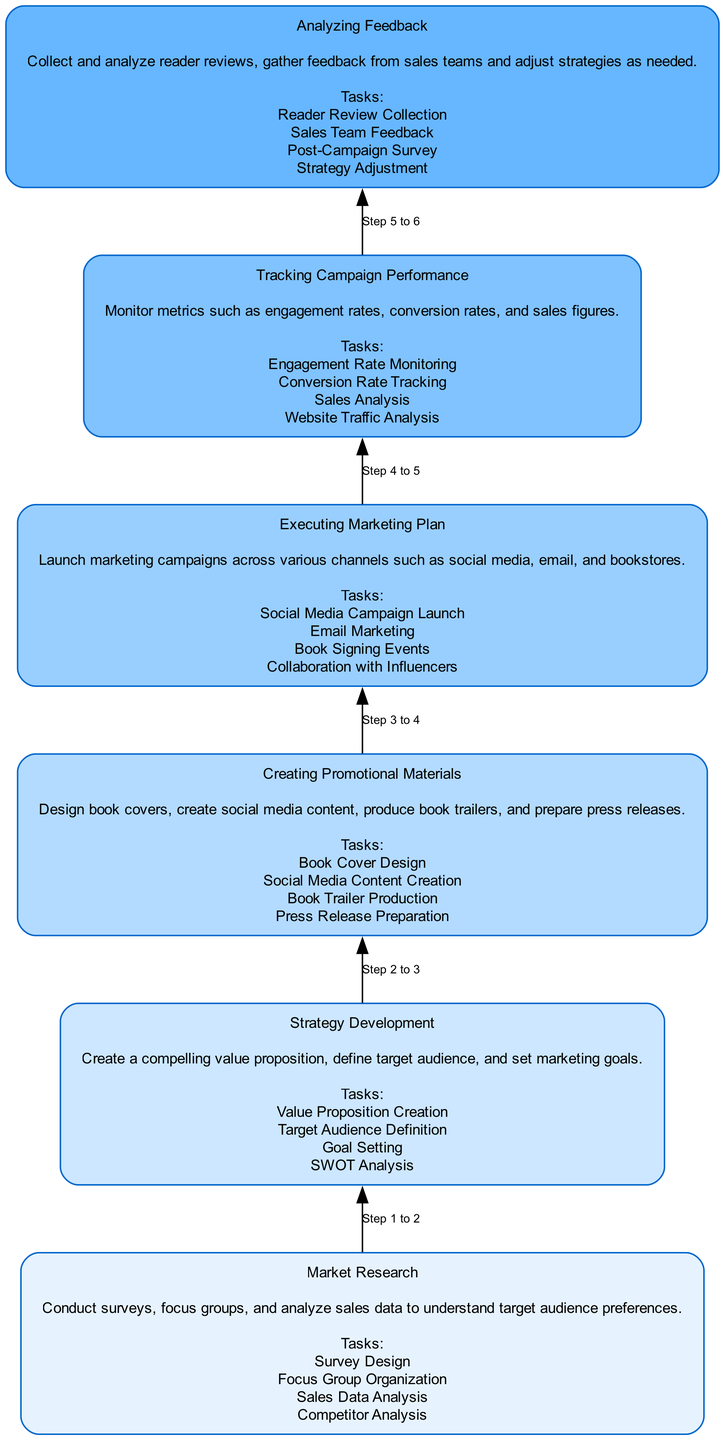What is the topmost node in the diagram? The topmost node is "Analyzing Feedback". In a flowchart that goes from bottom to top, the topmost node represents the final step in the process.
Answer: Analyzing Feedback How many nodes are there in total? There are six nodes, each representing a step in the marketing campaign process. By counting the levels from Market Research at the bottom to Analyzing Feedback at the top, we see there are six distinct steps.
Answer: 6 What is the main task associated with "Creating Promotional Materials"? The main task associated with "Creating Promotional Materials" includes designing book covers. Each node defines several tasks, and one of the specific tasks mentioned is book cover design.
Answer: Book Cover Design What is the relationship between "Market Research" and "Strategy Development"? "Market Research" is a prerequisite for "Strategy Development". In flowcharts, the direction of the arrow indicates the flow of the process; thus, Market Research leads directly to Strategy Development.
Answer: Prerequisite Which step comes after "Executing Marketing Plan"? The step that follows "Executing Marketing Plan" is "Tracking Campaign Performance". The arrows in the flowchart show that after executing the plan, tracking the results is the next logical step.
Answer: Tracking Campaign Performance What are two tasks from the "Strategy Development" node? Two tasks from "Strategy Development" are Value Proposition Creation and Goal Setting. The list of tasks presented in each node allows us to list any two from that section.
Answer: Value Proposition Creation, Goal Setting What is the color of the "Creating Promotional Materials" node? The "Creating Promotional Materials" node is colored #B3DBFF. Each node has a unique color assigned based on its level, and this specific node level corresponds to the third color in the defined palette.
Answer: #B3DBFF What metrics are monitored in the "Tracking Campaign Performance" phase? Engagement rates, conversion rates, and sales figures are monitored. The tasks listed indicate specific metrics that should be tracked during this phase.
Answer: Engagement rates, conversion rates, sales figures Which node focuses on gathering reader insights? The node that focuses on gathering reader insights is "Analyzing Feedback". This phase includes collecting and analyzing reader reviews to adjust strategies based on reader input.
Answer: Analyzing Feedback 